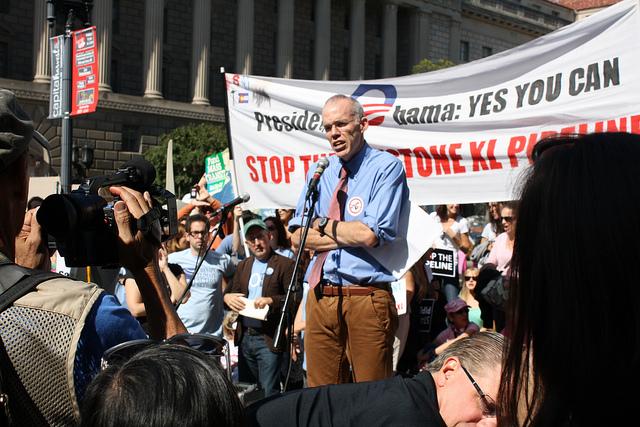Is this a circus?
Be succinct. No. Is this a political demonstration?
Quick response, please. Yes. What does the banner say?
Quick response, please. President obama: yes you can. What is the man in the beige vest holding?
Write a very short answer. Camera. 